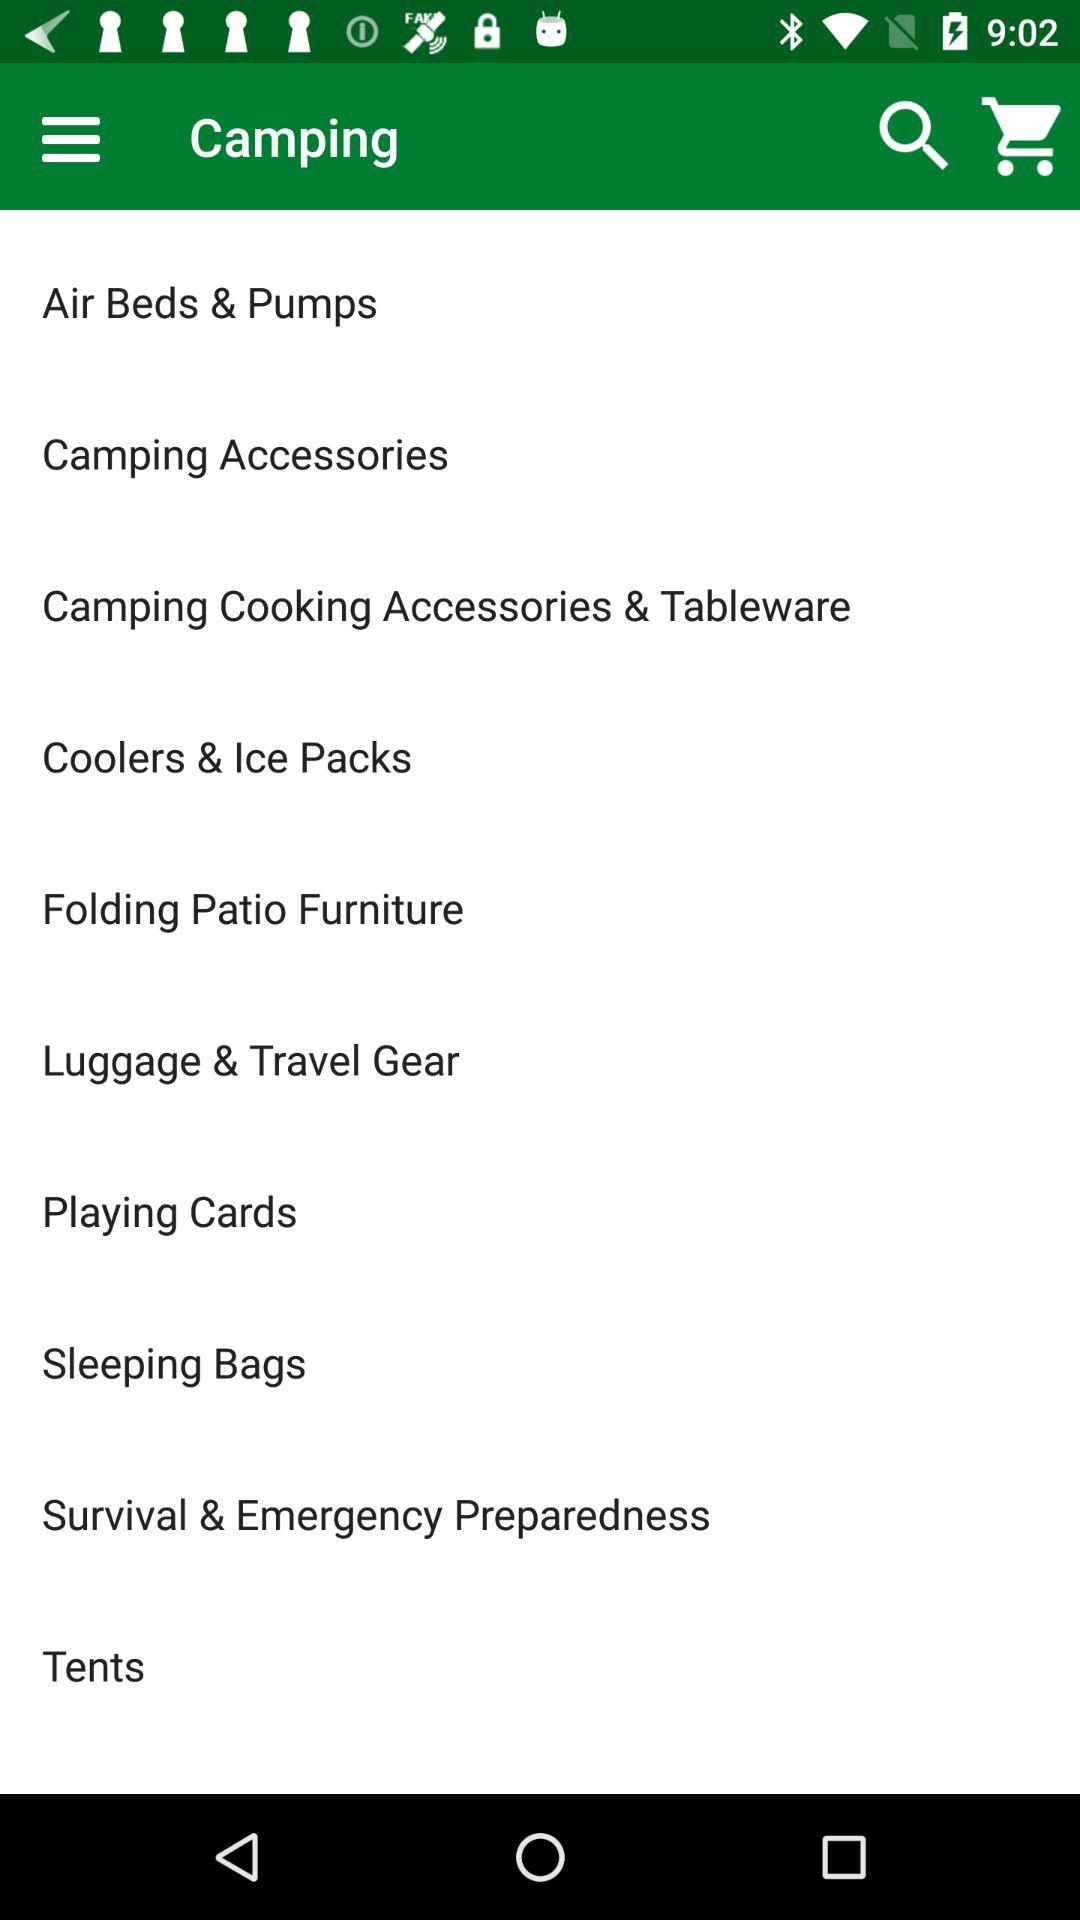How many items are in the Camping category?
Answer the question using a single word or phrase. 10 